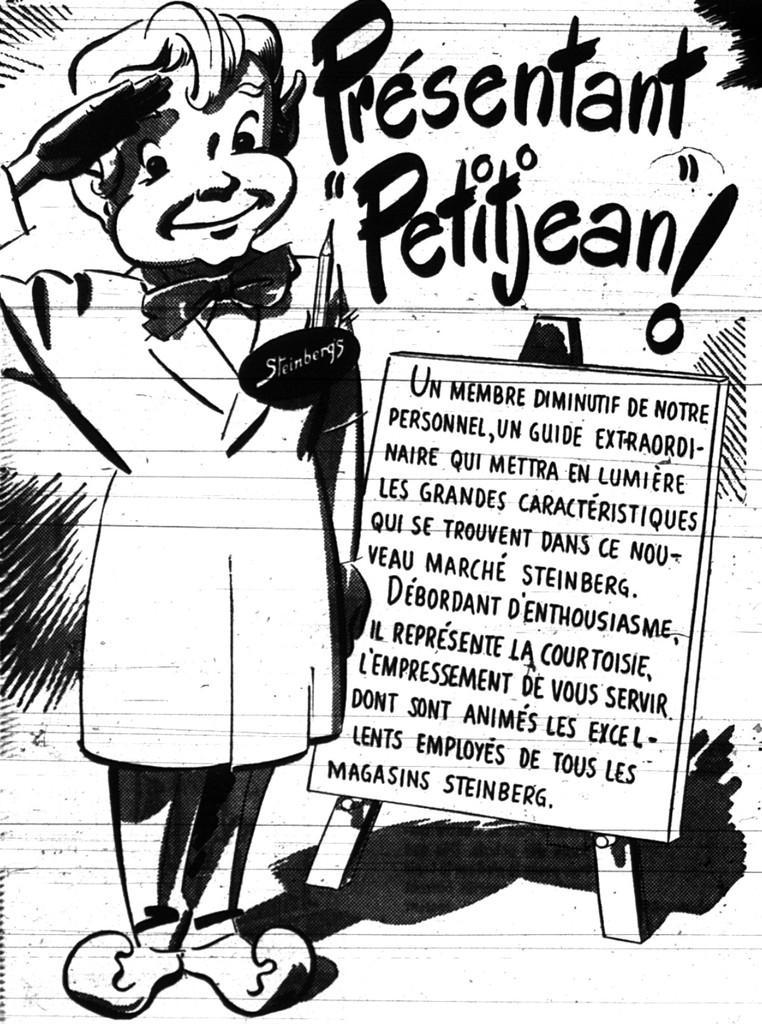How would you summarize this image in a sentence or two? In this image we can see sketch of a person. Also something is written on the image. 